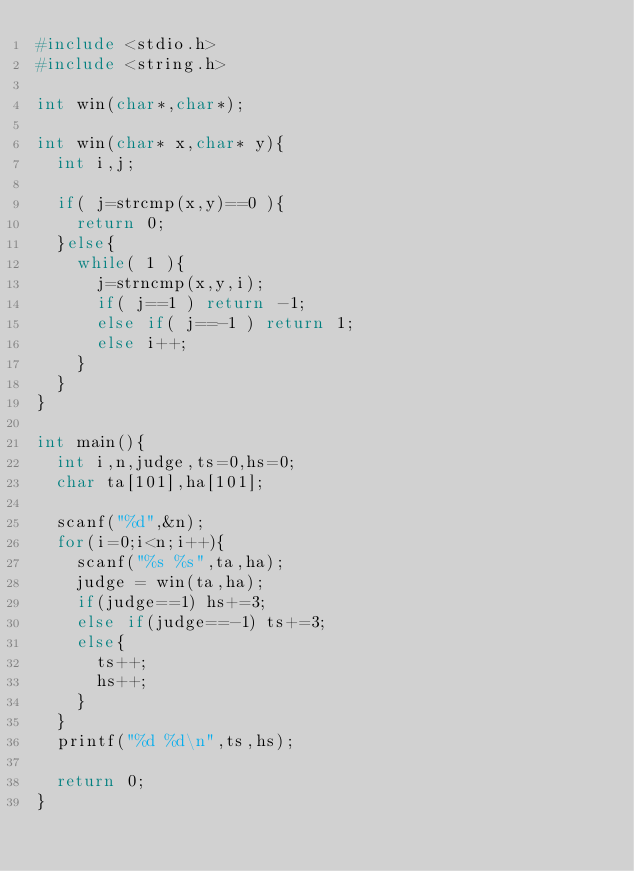Convert code to text. <code><loc_0><loc_0><loc_500><loc_500><_C_>#include <stdio.h>
#include <string.h>

int win(char*,char*);

int win(char* x,char* y){
  int i,j;
  
  if( j=strcmp(x,y)==0 ){
    return 0;
  }else{
    while( 1 ){
      j=strncmp(x,y,i);
      if( j==1 ) return -1;
      else if( j==-1 ) return 1;
      else i++;
    }
  }
}

int main(){
  int i,n,judge,ts=0,hs=0;
  char ta[101],ha[101];
    
  scanf("%d",&n);
  for(i=0;i<n;i++){
    scanf("%s %s",ta,ha);
    judge = win(ta,ha);
    if(judge==1) hs+=3;
    else if(judge==-1) ts+=3;
    else{
      ts++;
      hs++;
    }
  }
  printf("%d %d\n",ts,hs);
  
  return 0;
}</code> 